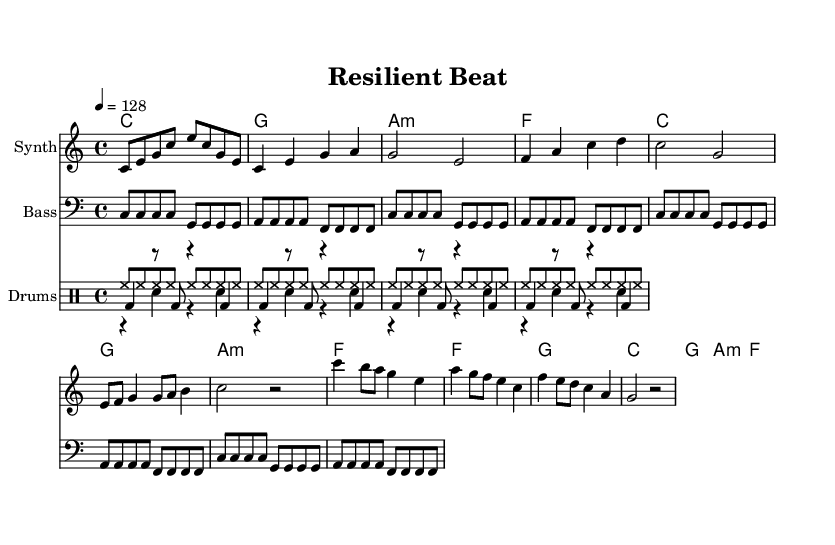What is the key signature of this music? The key signature is indicated at the beginning of the score. It shows C major, which has no sharps or flats.
Answer: C major What is the time signature of this music? The time signature is found in the first measures and sets the rhythmic pattern by dividing each measure into beats. Here, it shows 4/4, meaning there are four beats per measure.
Answer: 4/4 What is the tempo marking for this piece? The tempo is indicated in the score with "4 = 128," meaning there are 128 beats per minute, giving it a lively pace suitable for dance music.
Answer: 128 How many measures are in the chorus section? The chorus consists of four lines of lyrics, each line representing a measure, totaling four measures.
Answer: 4 What type of chord progression is used in the verse? The chord progression in the verse follows a common pattern in dance music, using chords that provide uplifting harmonies. The specified chords are C, G, A minor, and F, repeated.
Answer: C, G, A minor, F What is the primary theme expressed in the lyrics? A close reading of the lyrics reveals a focus on overcoming challenges and promoting positivity. The lyrics specifically mention resilience and community support in the face of difficulties.
Answer: Overcoming challenges What instrument is primarily used to play the melody? The score specifies the instrument for the melody as "Synth," indicating it should be played using a synthesizer sound, typical for electronic dance music.
Answer: Synth 